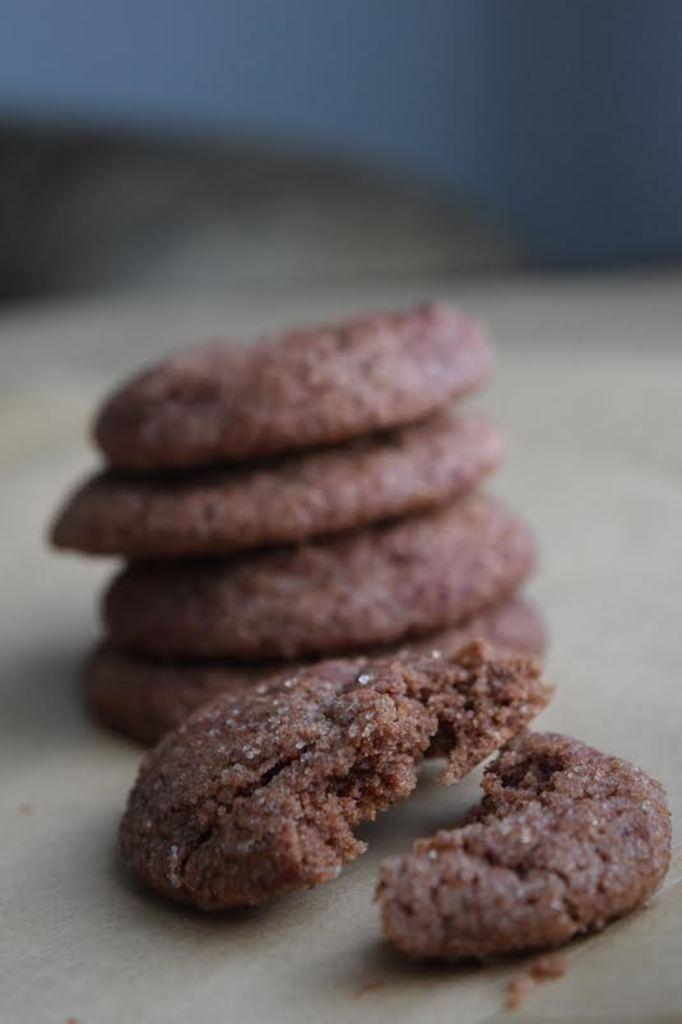Describe this image in one or two sentences. In the image I can see food items on a white color surface. The background of the image is blurred. 